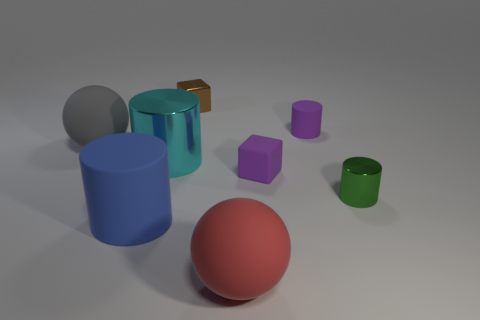Subtract all small purple cylinders. How many cylinders are left? 3 Add 1 red metal cylinders. How many objects exist? 9 Subtract all cyan cylinders. How many cylinders are left? 3 Subtract all blocks. How many objects are left? 6 Subtract 1 cylinders. How many cylinders are left? 3 Add 1 purple blocks. How many purple blocks exist? 2 Subtract 0 brown cylinders. How many objects are left? 8 Subtract all gray cylinders. Subtract all yellow balls. How many cylinders are left? 4 Subtract all yellow spheres. How many yellow blocks are left? 0 Subtract all red spheres. Subtract all green metallic objects. How many objects are left? 6 